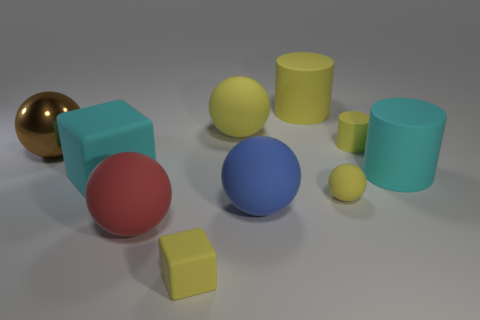Subtract 1 spheres. How many spheres are left? 4 Subtract all blue balls. How many balls are left? 4 Subtract all large blue rubber balls. How many balls are left? 4 Subtract all purple spheres. Subtract all red cylinders. How many spheres are left? 5 Subtract all cubes. How many objects are left? 8 Add 9 gray rubber cylinders. How many gray rubber cylinders exist? 9 Subtract 0 brown blocks. How many objects are left? 10 Subtract all red rubber things. Subtract all cyan objects. How many objects are left? 7 Add 9 large yellow rubber cylinders. How many large yellow rubber cylinders are left? 10 